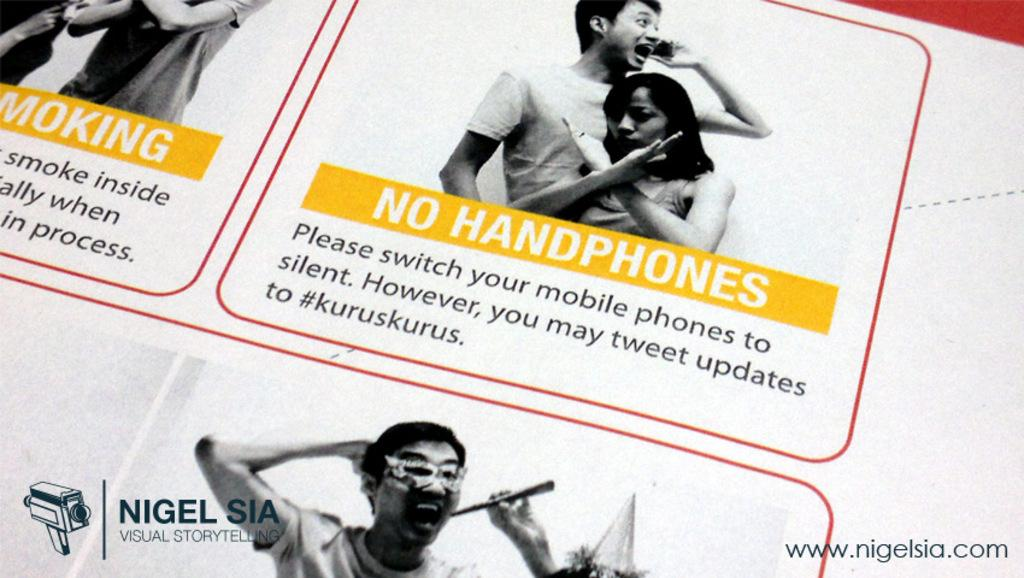What can be observed about the nature of the image? The image is edited. What is located in the center of the image? There is text in the center of the image. What are the people at the top of the image doing? There are people doing actions at the top of the image. What are the people at the bottom of the image doing? There are people doing actions at the bottom of the image. What type of eggnog is being served to the passengers in the image? There is no eggnog or passengers present in the image; it features text and people doing actions. 